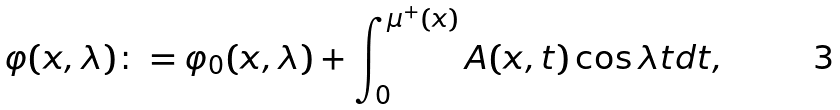Convert formula to latex. <formula><loc_0><loc_0><loc_500><loc_500>\varphi ( x , \lambda ) \colon = \varphi _ { 0 } ( x , \lambda ) + \int _ { 0 } ^ { \mu ^ { + } ( x ) } A ( x , t ) \cos \lambda t d t ,</formula> 